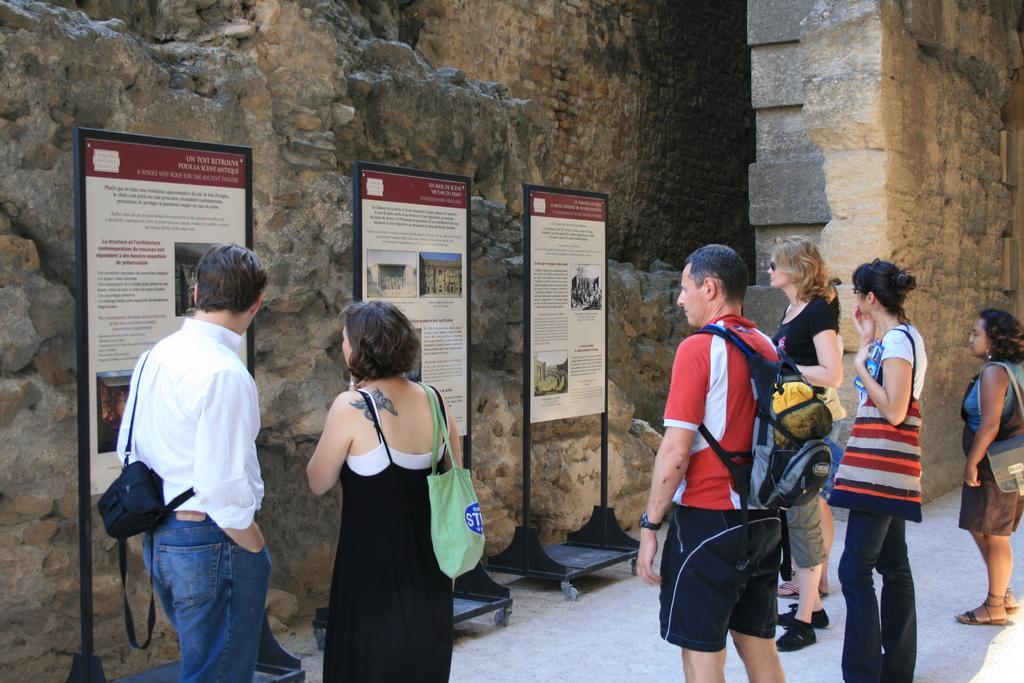How would you summarize this image in a sentence or two? There are few people standing. They are holding the bags. These are the boards with the posters attached to it. This looks like an historical building. 